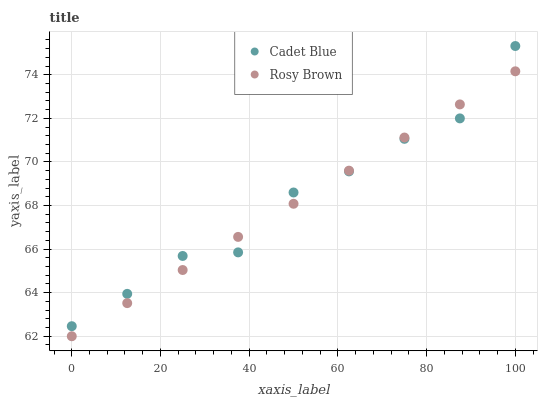Does Rosy Brown have the minimum area under the curve?
Answer yes or no. Yes. Does Cadet Blue have the maximum area under the curve?
Answer yes or no. Yes. Does Cadet Blue have the minimum area under the curve?
Answer yes or no. No. Is Rosy Brown the smoothest?
Answer yes or no. Yes. Is Cadet Blue the roughest?
Answer yes or no. Yes. Is Cadet Blue the smoothest?
Answer yes or no. No. Does Rosy Brown have the lowest value?
Answer yes or no. Yes. Does Cadet Blue have the lowest value?
Answer yes or no. No. Does Cadet Blue have the highest value?
Answer yes or no. Yes. Does Cadet Blue intersect Rosy Brown?
Answer yes or no. Yes. Is Cadet Blue less than Rosy Brown?
Answer yes or no. No. Is Cadet Blue greater than Rosy Brown?
Answer yes or no. No. 